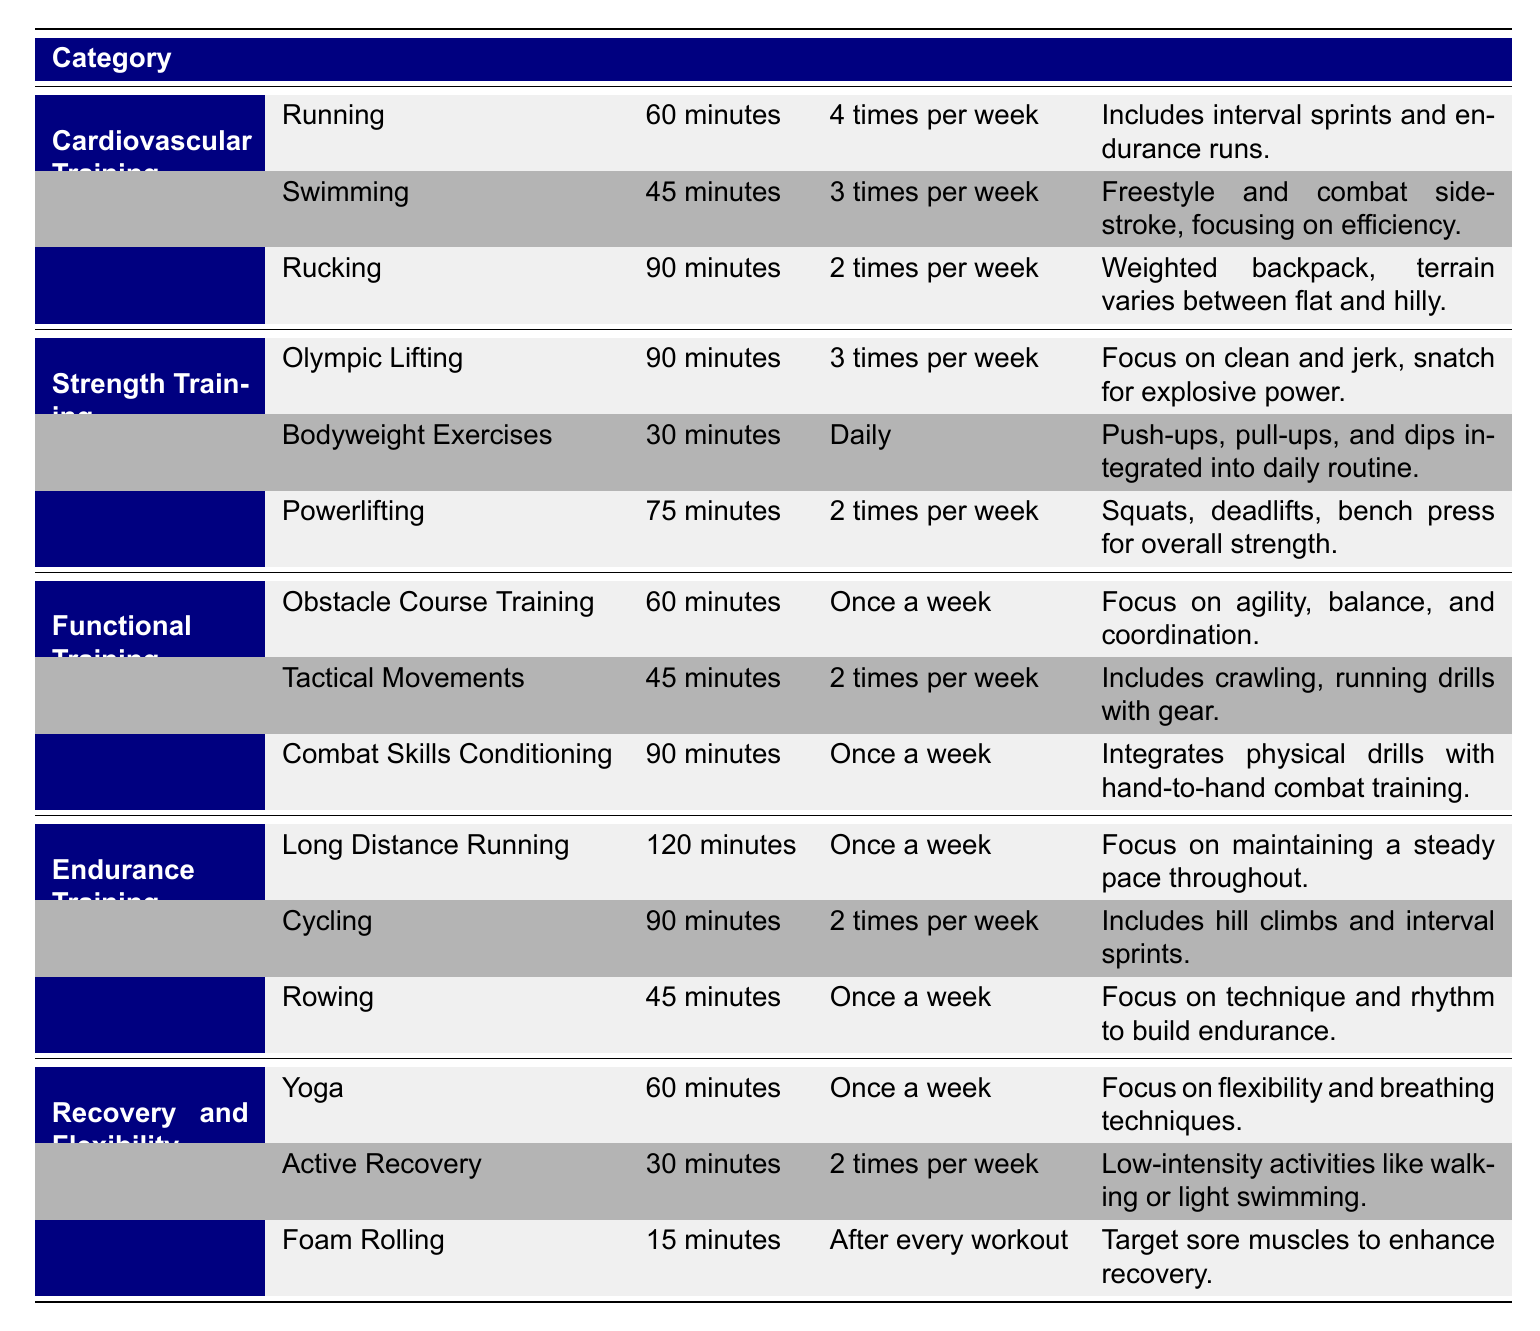What is the duration of the yoga activity in the Recovery and Flexibility category? The table shows that yoga lasts for 60 minutes under the Recovery and Flexibility category.
Answer: 60 minutes How often is swimming performed in the Cardiovascular Training category? The frequency of swimming is listed as 3 times per week in the Cardiovascular Training category.
Answer: 3 times per week Which strength training activity has the longest duration? From the listed activities, Olympic Lifting has the longest duration of 90 minutes, making it the longest in the Strength Training category.
Answer: Olympic Lifting Is the frequency of rowing greater than or equal to the frequency of rucking? Rowing is performed once a week, while rucking is done 2 times per week; therefore, the frequency of rowing is not greater than or equal to that of rucking.
Answer: No What is the total duration of activities in the Functional Training category? The durations are 60 minutes (Obstacle Course Training) + 45 minutes (Tactical Movements) + 90 minutes (Combat Skills Conditioning), totaling 195 minutes.
Answer: 195 minutes Which activity in the Endurance Training category focuses on maintaining a steady pace? The table indicates that the Long Distance Running activity emphasizes maintaining a steady pace throughout its duration.
Answer: Long Distance Running What is the average duration of activities in the Recovery and Flexibility category? The durations are 60 minutes (Yoga) + 30 minutes (Active Recovery) + 15 minutes (Foam Rolling), totaling 105 minutes. There are 3 activities, so the average duration is 105/3 = 35 minutes.
Answer: 35 minutes How many times per week is bodyweight training conducted? Bodyweight Exercises are listed as a daily activity, which means they are performed 7 times a week.
Answer: 7 times per week Is there an activity in the Cardiovascular Training category that is performed 2 times per week? Yes, the table shows that Rucking is conducted 2 times per week in the Cardiovascular Training category.
Answer: Yes 